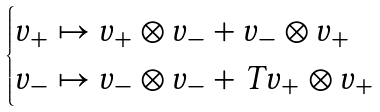<formula> <loc_0><loc_0><loc_500><loc_500>\begin{cases} v _ { + } \mapsto v _ { + } \otimes v _ { - } + v _ { - } \otimes v _ { + } & \\ v _ { - } \mapsto v _ { - } \otimes v _ { - } + T v _ { + } \otimes v _ { + } & \end{cases}</formula> 